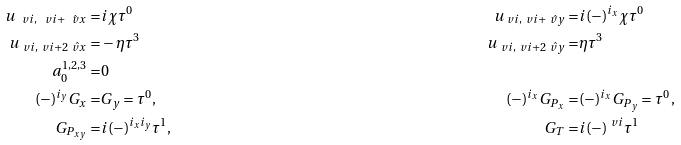<formula> <loc_0><loc_0><loc_500><loc_500>u _ { \ v i , \ v i + \hat { \ v x } } = & i \chi \tau ^ { 0 } & u _ { \ v i , \ v i + \hat { \ v y } } = & i ( - ) ^ { i _ { x } } \chi \tau ^ { 0 } \\ u _ { \ v i , \ v i + 2 \hat { \ v x } } = & - \eta \tau ^ { 3 } & u _ { \ v i , \ v i + 2 \hat { \ v y } } = & \eta \tau ^ { 3 } \\ a ^ { 1 , 2 , 3 } _ { 0 } = & 0 \\ ( - ) ^ { i _ { y } } G _ { x } = & G _ { y } = \tau ^ { 0 } , & ( - ) ^ { i _ { x } } G _ { P _ { x } } = & ( - ) ^ { i _ { x } } G _ { P _ { y } } = \tau ^ { 0 } , \\ G _ { P _ { x y } } = & i ( - ) ^ { i _ { x } i _ { y } } \tau ^ { 1 } , & G _ { T } = & i ( - ) ^ { \ v i } \tau ^ { 1 }</formula> 